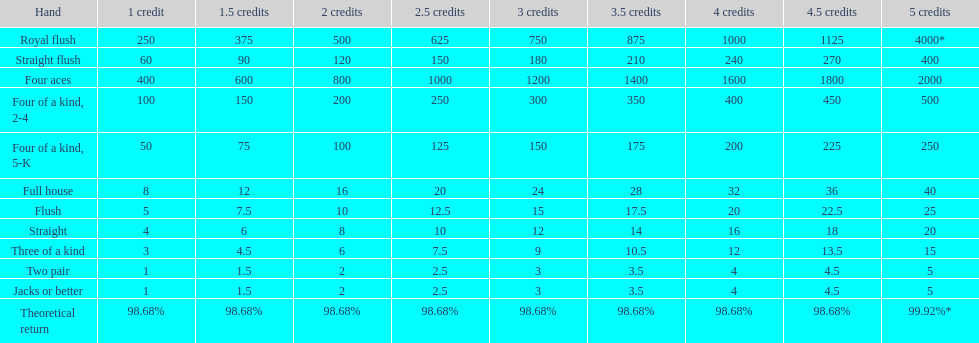What's the best type of four of a kind to win? Four of a kind, 2-4. 